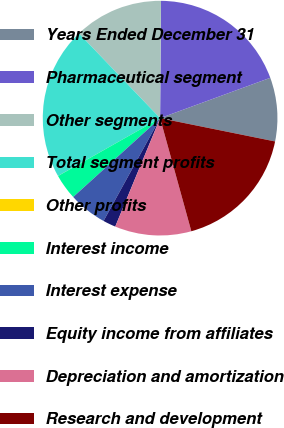<chart> <loc_0><loc_0><loc_500><loc_500><pie_chart><fcel>Years Ended December 31<fcel>Pharmaceutical segment<fcel>Other segments<fcel>Total segment profits<fcel>Other profits<fcel>Interest income<fcel>Interest expense<fcel>Equity income from affiliates<fcel>Depreciation and amortization<fcel>Research and development<nl><fcel>8.77%<fcel>19.29%<fcel>12.28%<fcel>21.04%<fcel>0.01%<fcel>3.52%<fcel>5.27%<fcel>1.76%<fcel>10.53%<fcel>17.53%<nl></chart> 